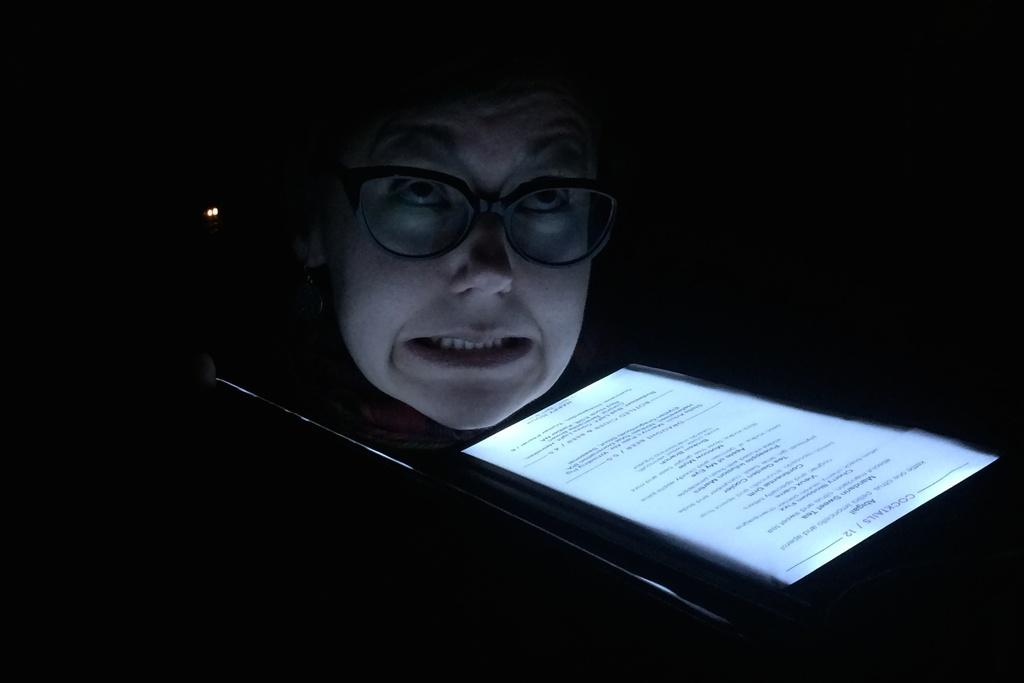Who is present in the image? There is a woman in the image. What is located in the foreground of the image? There is a paper in the foreground of the image. What can be seen on the paper? There is text on the paper. What is visible in the background of the image? There is a light in the background of the image. What is the color of the background in the image? The background of the image is black. What type of curve is visible on the flag in the image? There is no flag present in the image, so it is not possible to determine the type of curve on it. 